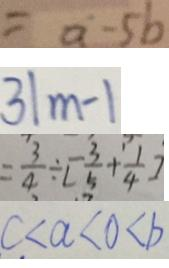Convert formula to latex. <formula><loc_0><loc_0><loc_500><loc_500>= a - 5 b 
 3 \vert m - 1 
 = \frac { 3 } { 4 } \div [ \frac { 3 } { 5 } + \frac { 1 } { 4 } ] 
 c < a < 0 < b</formula> 